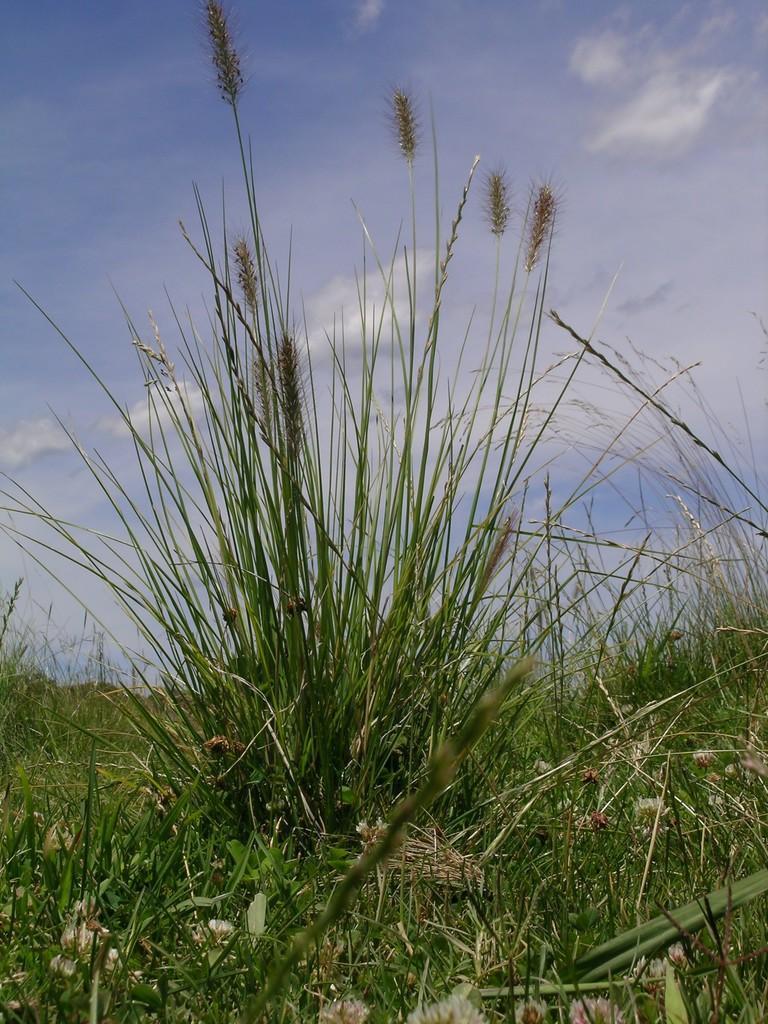In one or two sentences, can you explain what this image depicts? In this picture we can see grass at the bottom, there is the sky at the top of the picture. 